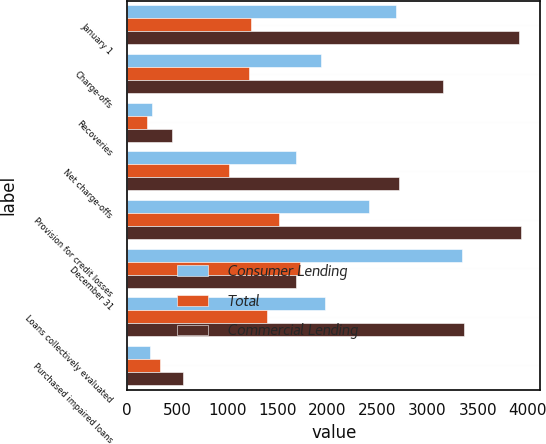Convert chart to OTSL. <chart><loc_0><loc_0><loc_500><loc_500><stacked_bar_chart><ecel><fcel>January 1<fcel>Charge-offs<fcel>Recoveries<fcel>Net charge-offs<fcel>Provision for credit losses<fcel>December 31<fcel>Loans collectively evaluated<fcel>Purchased impaired loans<nl><fcel>Consumer Lending<fcel>2680<fcel>1935<fcel>246<fcel>1689<fcel>2418<fcel>3345<fcel>1973<fcel>224<nl><fcel>Total<fcel>1237<fcel>1220<fcel>198<fcel>1022<fcel>1512<fcel>1727<fcel>1395<fcel>332<nl><fcel>Commercial Lending<fcel>3917<fcel>3155<fcel>444<fcel>2711<fcel>3930<fcel>1689<fcel>3368<fcel>556<nl></chart> 